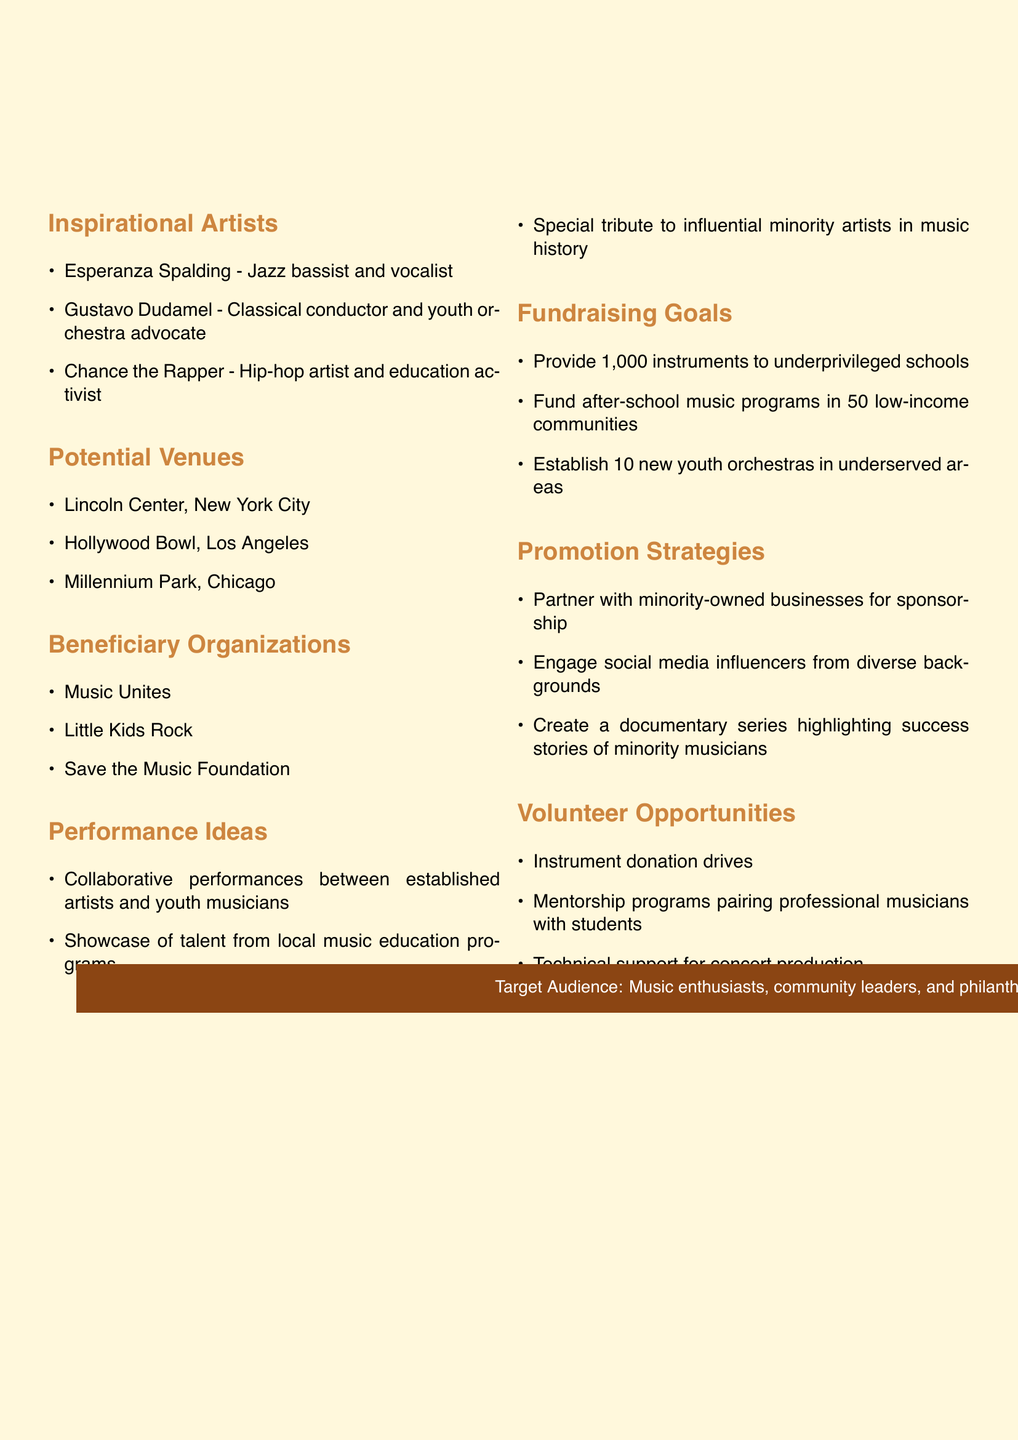What is the title of the concert? The title of the concert is presented at the top of the document.
Answer: Harmony for Hope: Empowering Youth Through Music Who are the inspirational artists listed? The document lists three inspirational artists under a specific section.
Answer: Esperanza Spalding, Gustavo Dudamel, Chance the Rapper How many instruments is the concert aiming to provide? The fundraising goals include a specific number of instruments to be provided to schools.
Answer: 1,000 Which cities are potential venues for the concert? The document identifies three potential venues in different cities for the concert.
Answer: New York City, Los Angeles, Chicago What is one of the performance ideas? The document lists performance ideas, indicating the scope of the concert's programming.
Answer: Collaborative performances between established artists and youth musicians What type of organizations will benefit from the concert? The document mentions specific organizations that will benefit from the concert proceeds.
Answer: Music Unites, Little Kids Rock, Save the Music Foundation What is a strategy for promoting the concert? The document provides several strategies to engage the target audience.
Answer: Partner with minority-owned businesses for sponsorship How many new youth orchestras does the fundraising aim to establish? This is a specific goal mentioned in the fundraising section of the document.
Answer: 10 What is one of the volunteer opportunities mentioned? The document outlines various ways individuals can contribute to the concert effort.
Answer: Instrument donation drives 